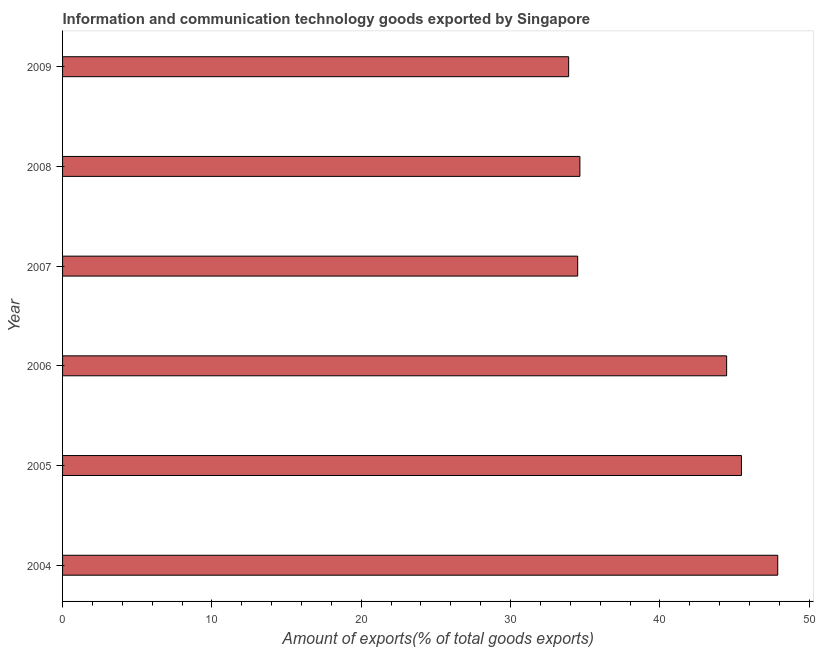Does the graph contain grids?
Provide a short and direct response. No. What is the title of the graph?
Offer a very short reply. Information and communication technology goods exported by Singapore. What is the label or title of the X-axis?
Offer a very short reply. Amount of exports(% of total goods exports). What is the amount of ict goods exports in 2004?
Make the answer very short. 47.89. Across all years, what is the maximum amount of ict goods exports?
Provide a short and direct response. 47.89. Across all years, what is the minimum amount of ict goods exports?
Provide a short and direct response. 33.89. What is the sum of the amount of ict goods exports?
Give a very brief answer. 240.85. What is the difference between the amount of ict goods exports in 2004 and 2006?
Offer a very short reply. 3.42. What is the average amount of ict goods exports per year?
Keep it short and to the point. 40.14. What is the median amount of ict goods exports?
Offer a terse response. 39.56. Do a majority of the years between 2006 and 2007 (inclusive) have amount of ict goods exports greater than 42 %?
Offer a terse response. No. Is the amount of ict goods exports in 2006 less than that in 2009?
Ensure brevity in your answer.  No. What is the difference between the highest and the second highest amount of ict goods exports?
Give a very brief answer. 2.43. What is the difference between the highest and the lowest amount of ict goods exports?
Your answer should be very brief. 14. How many bars are there?
Provide a succinct answer. 6. Are all the bars in the graph horizontal?
Ensure brevity in your answer.  Yes. How many years are there in the graph?
Keep it short and to the point. 6. What is the difference between two consecutive major ticks on the X-axis?
Offer a very short reply. 10. What is the Amount of exports(% of total goods exports) of 2004?
Offer a terse response. 47.89. What is the Amount of exports(% of total goods exports) in 2005?
Keep it short and to the point. 45.46. What is the Amount of exports(% of total goods exports) of 2006?
Offer a very short reply. 44.47. What is the Amount of exports(% of total goods exports) of 2007?
Offer a very short reply. 34.49. What is the Amount of exports(% of total goods exports) in 2008?
Offer a terse response. 34.64. What is the Amount of exports(% of total goods exports) in 2009?
Provide a succinct answer. 33.89. What is the difference between the Amount of exports(% of total goods exports) in 2004 and 2005?
Your response must be concise. 2.43. What is the difference between the Amount of exports(% of total goods exports) in 2004 and 2006?
Offer a very short reply. 3.42. What is the difference between the Amount of exports(% of total goods exports) in 2004 and 2007?
Ensure brevity in your answer.  13.4. What is the difference between the Amount of exports(% of total goods exports) in 2004 and 2008?
Provide a short and direct response. 13.25. What is the difference between the Amount of exports(% of total goods exports) in 2004 and 2009?
Your answer should be compact. 14. What is the difference between the Amount of exports(% of total goods exports) in 2005 and 2006?
Provide a short and direct response. 0.99. What is the difference between the Amount of exports(% of total goods exports) in 2005 and 2007?
Offer a terse response. 10.97. What is the difference between the Amount of exports(% of total goods exports) in 2005 and 2008?
Your answer should be compact. 10.82. What is the difference between the Amount of exports(% of total goods exports) in 2005 and 2009?
Ensure brevity in your answer.  11.57. What is the difference between the Amount of exports(% of total goods exports) in 2006 and 2007?
Provide a short and direct response. 9.98. What is the difference between the Amount of exports(% of total goods exports) in 2006 and 2008?
Your answer should be very brief. 9.83. What is the difference between the Amount of exports(% of total goods exports) in 2006 and 2009?
Make the answer very short. 10.58. What is the difference between the Amount of exports(% of total goods exports) in 2007 and 2008?
Give a very brief answer. -0.15. What is the difference between the Amount of exports(% of total goods exports) in 2007 and 2009?
Offer a terse response. 0.61. What is the difference between the Amount of exports(% of total goods exports) in 2008 and 2009?
Your answer should be very brief. 0.75. What is the ratio of the Amount of exports(% of total goods exports) in 2004 to that in 2005?
Provide a succinct answer. 1.05. What is the ratio of the Amount of exports(% of total goods exports) in 2004 to that in 2006?
Offer a very short reply. 1.08. What is the ratio of the Amount of exports(% of total goods exports) in 2004 to that in 2007?
Provide a short and direct response. 1.39. What is the ratio of the Amount of exports(% of total goods exports) in 2004 to that in 2008?
Ensure brevity in your answer.  1.38. What is the ratio of the Amount of exports(% of total goods exports) in 2004 to that in 2009?
Offer a terse response. 1.41. What is the ratio of the Amount of exports(% of total goods exports) in 2005 to that in 2007?
Provide a short and direct response. 1.32. What is the ratio of the Amount of exports(% of total goods exports) in 2005 to that in 2008?
Ensure brevity in your answer.  1.31. What is the ratio of the Amount of exports(% of total goods exports) in 2005 to that in 2009?
Ensure brevity in your answer.  1.34. What is the ratio of the Amount of exports(% of total goods exports) in 2006 to that in 2007?
Your answer should be compact. 1.29. What is the ratio of the Amount of exports(% of total goods exports) in 2006 to that in 2008?
Provide a succinct answer. 1.28. What is the ratio of the Amount of exports(% of total goods exports) in 2006 to that in 2009?
Your response must be concise. 1.31. What is the ratio of the Amount of exports(% of total goods exports) in 2007 to that in 2008?
Provide a succinct answer. 1. What is the ratio of the Amount of exports(% of total goods exports) in 2008 to that in 2009?
Provide a short and direct response. 1.02. 